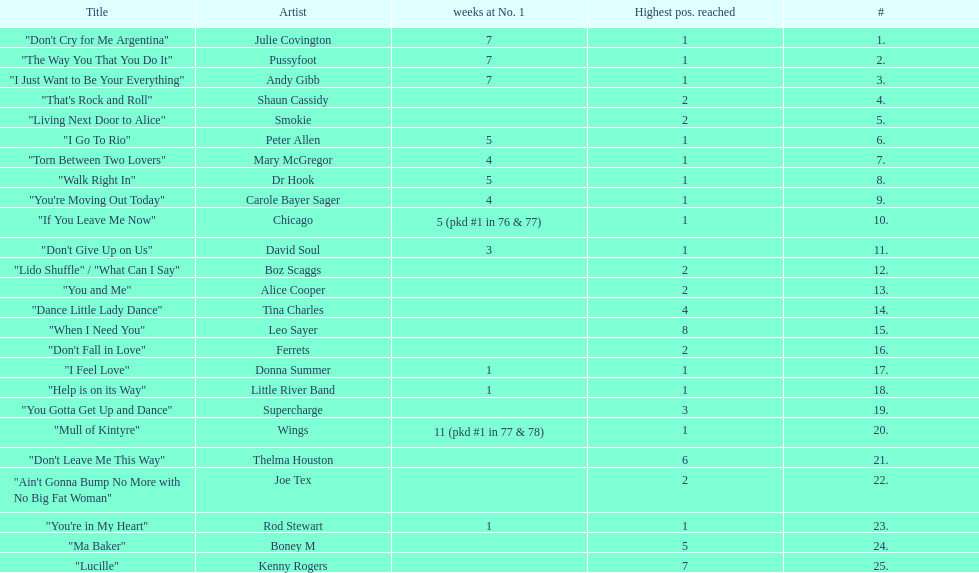What was the number of weeks that julie covington's single " don't cry for me argentinia," was at number 1 in 1977? 7. 